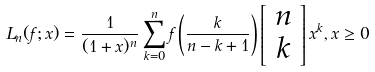Convert formula to latex. <formula><loc_0><loc_0><loc_500><loc_500>L _ { n } ( f ; x ) = \frac { 1 } { ( 1 + x ) ^ { n } } \sum _ { k = 0 } ^ { n } f \left ( \frac { k } { n - k + 1 } \right ) \left [ \begin{array} { c } n \\ k \end{array} \right ] x ^ { k } , x \geq 0</formula> 